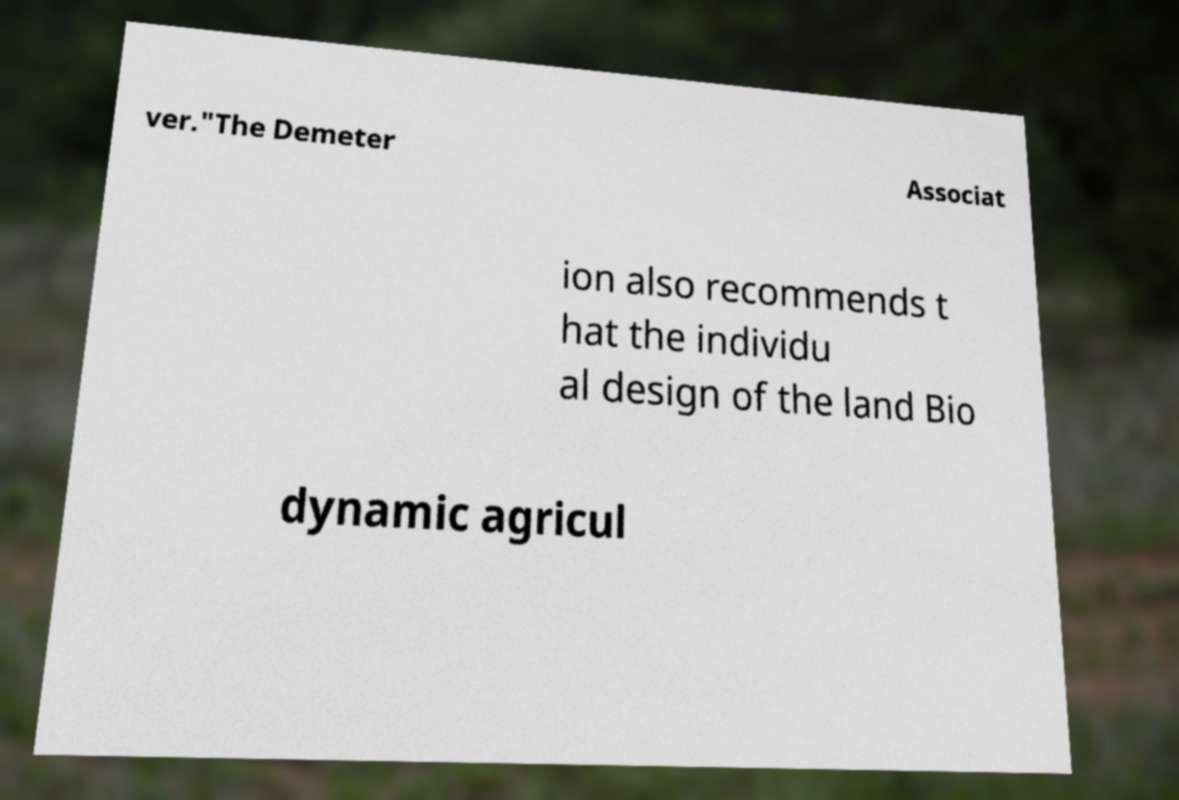Can you accurately transcribe the text from the provided image for me? ver."The Demeter Associat ion also recommends t hat the individu al design of the land Bio dynamic agricul 